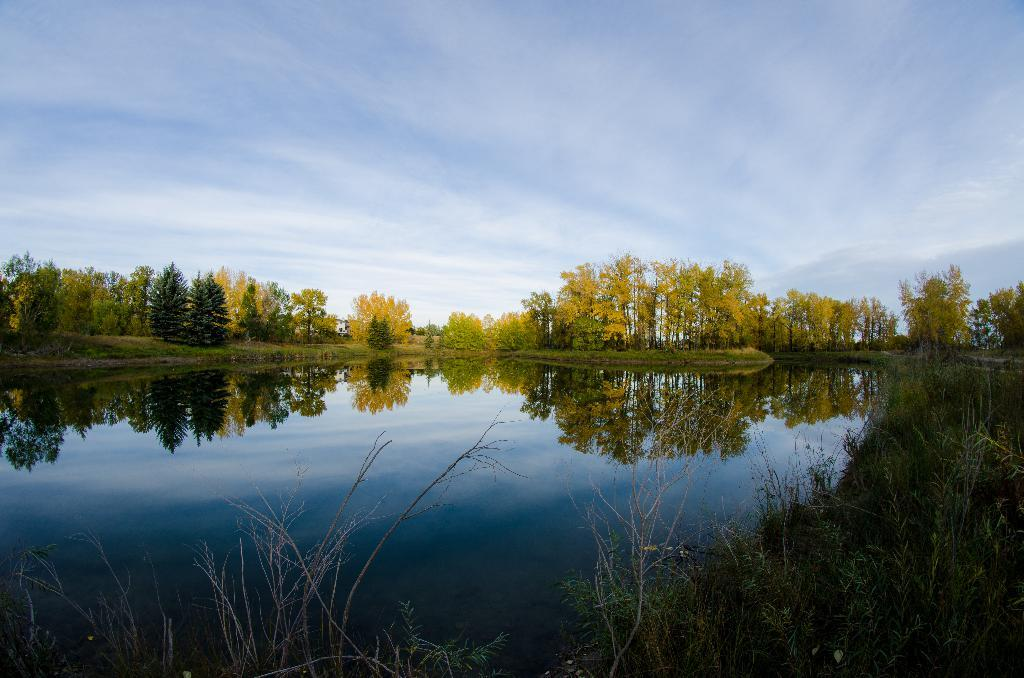What type of body of water is present in the image? There is a lake in the image. What can be seen on the bottom right of the image? There are plants on the bottom right of the image. What is visible in the background of the image? There are trees and the sky visible in the background of the image. What language is spoken by the apple in the image? There is no apple present in the image, and therefore no language can be spoken by it. 